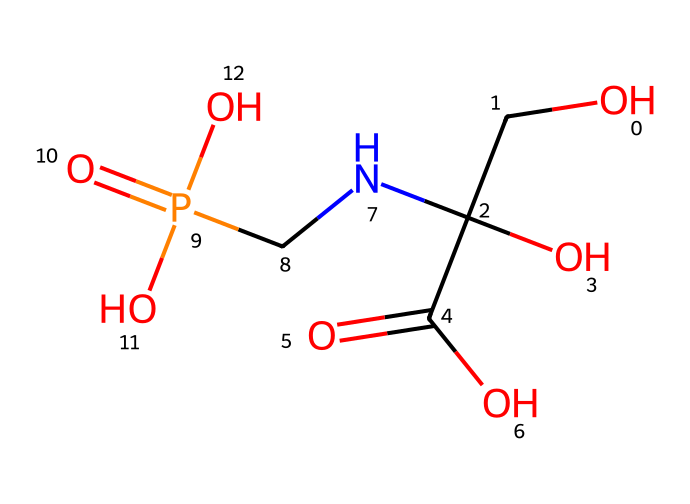What is the main functional group present in glyphosate? The structure contains a carboxylic acid functional group as indicated by the presence of the -COOH group. This group is commonly found in many organic acids.
Answer: carboxylic acid How many oxygen atoms are there in glyphosate? By analyzing the structure, there are four oxygen atoms present in the molecule. This includes those in both the carboxylic group and the phosphate group.
Answer: four What type of bond connects the phosphorus atom to the rest of the molecule? The phosphorus atom is involved in ester bonds with oxygen atoms, identifying it as a phosphonic acid derivative within this molecular structure.
Answer: ester bond What is the total number of hydrogen atoms in glyphosate? Counting the hydrogen atoms attached to the functional groups, there are six hydrogen atoms in glyphosate, including those from the hydroxyl and carboxylic groups.
Answer: six Does glyphosate contain any nitrogen atoms? Yes, glyphosate has one nitrogen atom present in its amino group, which contributes to its chemical properties and biological activity.
Answer: yes What is the molecular formula of glyphosate based on its structure? The SMILES representation provides the exact composition, which adds up to the molecular formula C3H8NO5P. By identifying each element and its count, this formula can be derived.
Answer: C3H8NO5P 